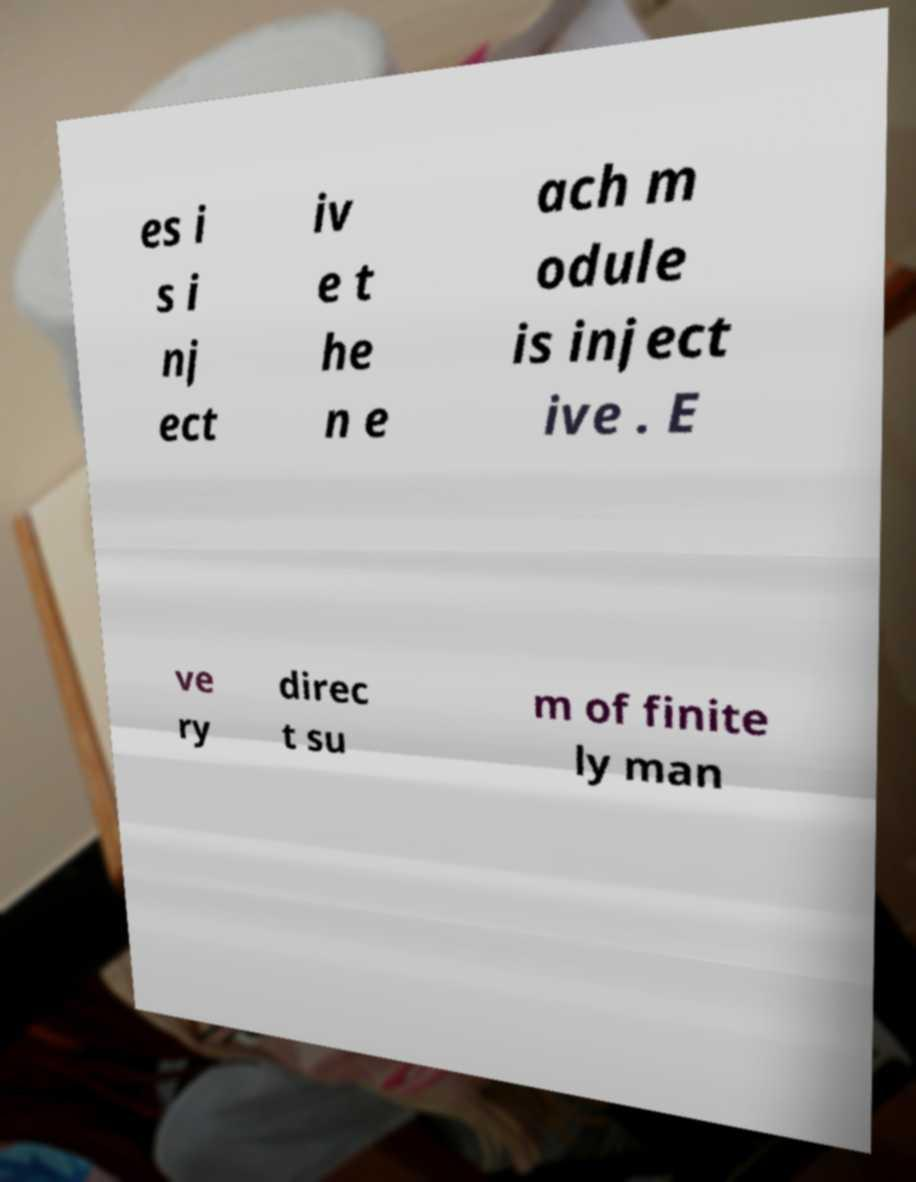Can you accurately transcribe the text from the provided image for me? es i s i nj ect iv e t he n e ach m odule is inject ive . E ve ry direc t su m of finite ly man 